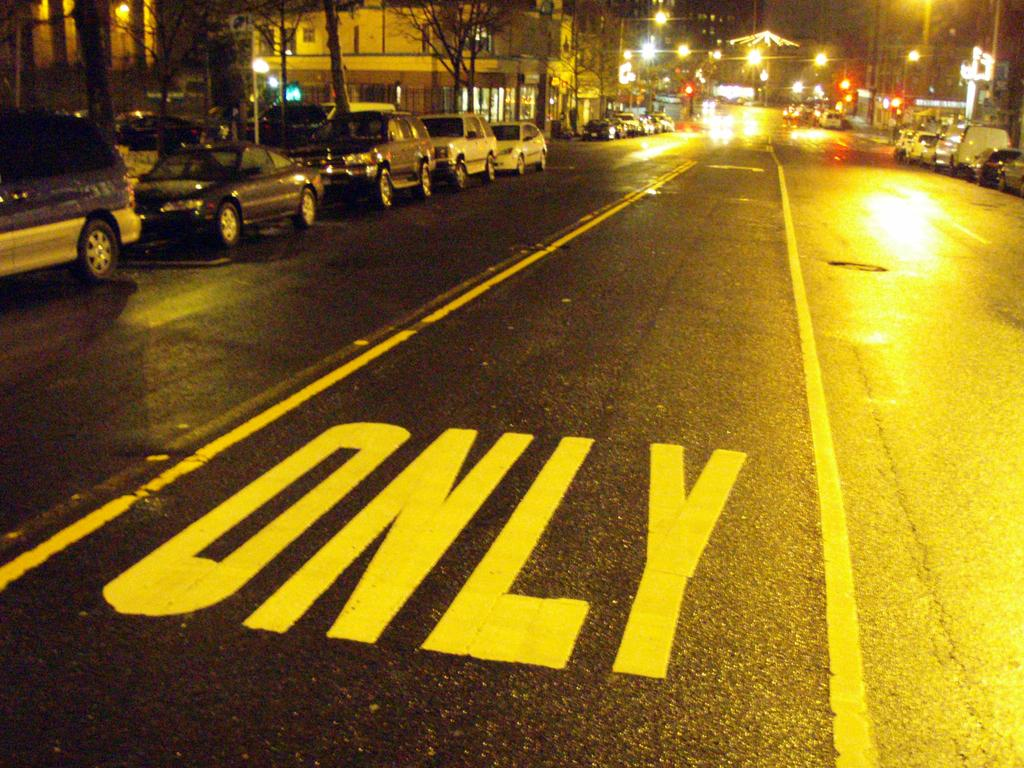<image>
Share a concise interpretation of the image provided. A street with One Way Only written on it is shown. 